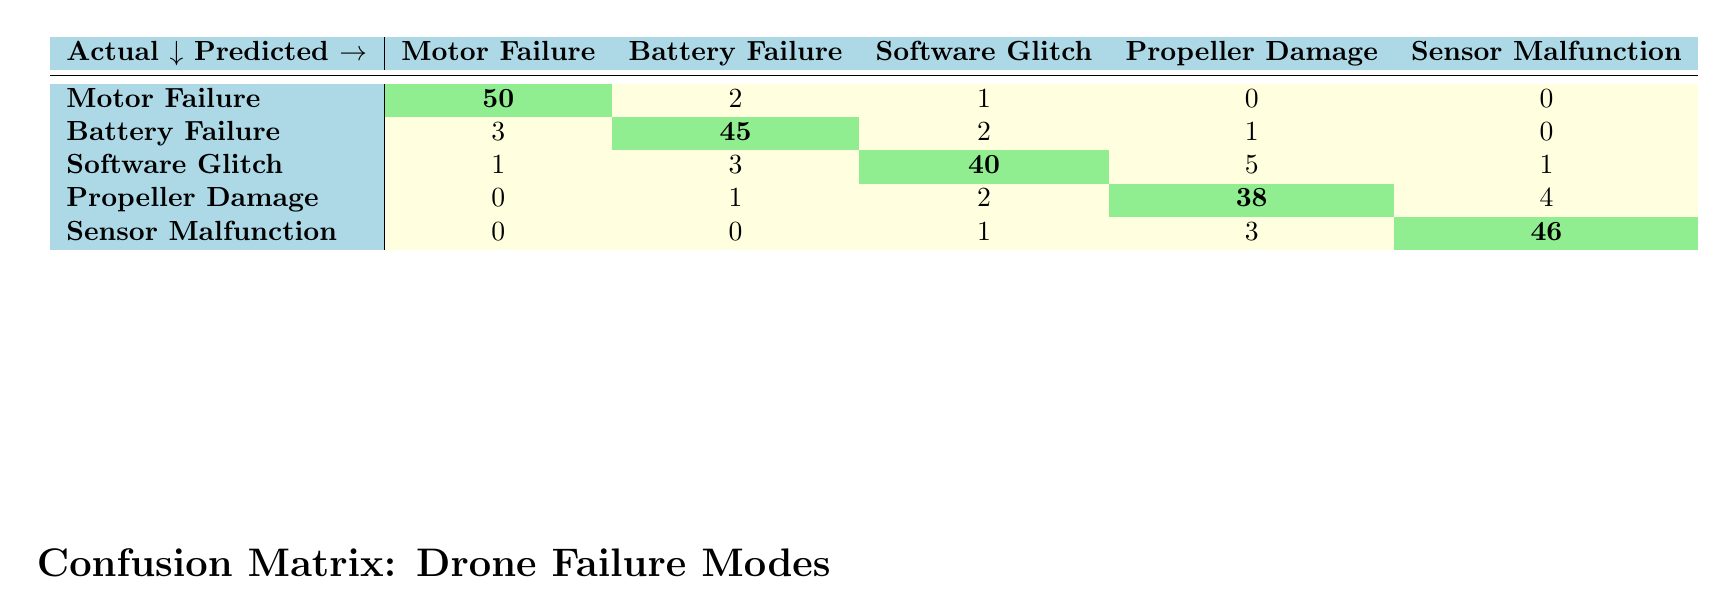What is the predicted count for Motor Failure? The predicted count for Motor Failure corresponds to the value found in the row labeled "Motor Failure" under the column "Motor Failure." According to the table, this value is 50.
Answer: 50 How many times was Battery Failure misclassified as Motor Failure? To find out how many times Battery Failure was misclassified as Motor Failure, we need to look at the row labeled "Battery Failure" and the column labeled "Motor Failure." The value there is 3.
Answer: 3 What is the total number of predictions made for Software Glitch? To calculate the total number of predictions made for Software Glitch, we sum the values in the row for "Software Glitch," which are 1, 3, 40, 5, and 1. Thus, the total predictions are 1 + 3 + 40 + 5 + 1 = 50.
Answer: 50 Is Sensor Malfunction predicted accurately more than 90% of the time? To determine if Sensor Malfunction is predicted accurately more than 90% of the time, we look at the diagonal value which represents accurate predictions (46) and compare it to the total predictions for Sensor Malfunction (50). Calculating 46 / 50 gives us 0.92 or 92%. Since 92% is greater than 90%, the answer is yes.
Answer: Yes What is the combined number of false positives for all failure modes? To find the combined number of false positives, we look at the non-diagonal entries in each row. Summing them up: for Motor Failure (2), Battery Failure (3+2+1=6), Software Glitch (1+3+5+1=10), Propeller Damage (1+2+4=7), and Sensor Malfunction (1+3=4). Thus, the total is 2 + 6 + 10 + 7 + 4 = 29.
Answer: 29 What is the count of misclassified Propeller Damage cases? The count of misclassified Propeller Damage cases can be found by adding the values in the column "Propeller Damage" except for the diagonal entry. The misclassifications are from Motor Failure (0), Battery Failure (1), Software Glitch (2), and Sensor Malfunction (3), summing these gives 0 + 1 + 2 + 3 = 6.
Answer: 6 Which failure mode has the highest count of correct predictions? To find the failure mode with the highest count of correct predictions, we compare the diagonal entries: Motor Failure (50), Battery Failure (45), Software Glitch (40), Propeller Damage (38), and Sensor Malfunction (46). The highest count is for Motor Failure, which has 50 correct predictions.
Answer: Motor Failure How often are Software Glitch cases misclassified as Battery Failure? To determine how often Software Glitch cases are misclassified as Battery Failure, we look at the row for Software Glitch and the column for Battery Failure. The value is 3, indicating this misclassification.
Answer: 3 